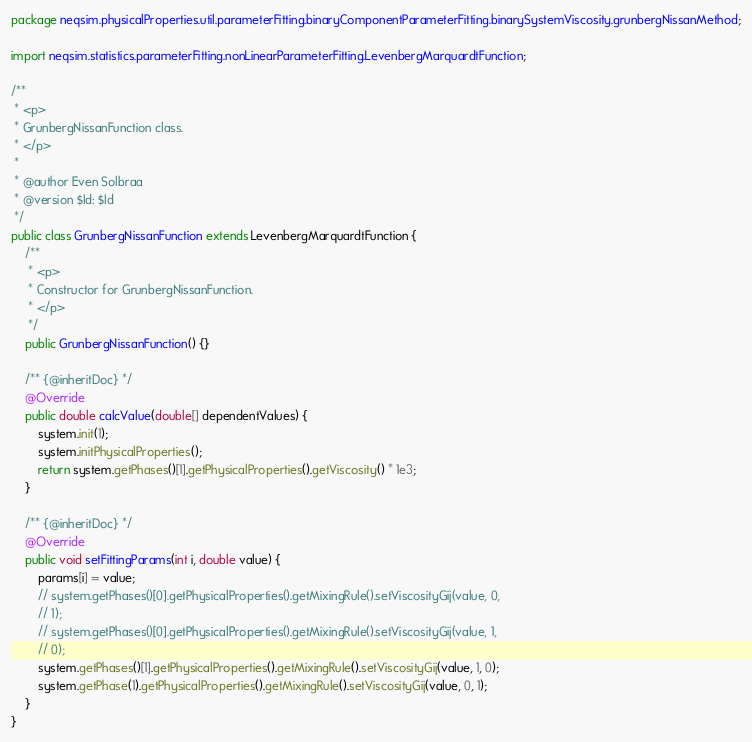<code> <loc_0><loc_0><loc_500><loc_500><_Java_>package neqsim.physicalProperties.util.parameterFitting.binaryComponentParameterFitting.binarySystemViscosity.grunbergNissanMethod;

import neqsim.statistics.parameterFitting.nonLinearParameterFitting.LevenbergMarquardtFunction;

/**
 * <p>
 * GrunbergNissanFunction class.
 * </p>
 *
 * @author Even Solbraa
 * @version $Id: $Id
 */
public class GrunbergNissanFunction extends LevenbergMarquardtFunction {
    /**
     * <p>
     * Constructor for GrunbergNissanFunction.
     * </p>
     */
    public GrunbergNissanFunction() {}

    /** {@inheritDoc} */
    @Override
    public double calcValue(double[] dependentValues) {
        system.init(1);
        system.initPhysicalProperties();
        return system.getPhases()[1].getPhysicalProperties().getViscosity() * 1e3;
    }

    /** {@inheritDoc} */
    @Override
    public void setFittingParams(int i, double value) {
        params[i] = value;
        // system.getPhases()[0].getPhysicalProperties().getMixingRule().setViscosityGij(value, 0,
        // 1);
        // system.getPhases()[0].getPhysicalProperties().getMixingRule().setViscosityGij(value, 1,
        // 0);
        system.getPhases()[1].getPhysicalProperties().getMixingRule().setViscosityGij(value, 1, 0);
        system.getPhase(1).getPhysicalProperties().getMixingRule().setViscosityGij(value, 0, 1);
    }
}
</code> 